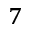Convert formula to latex. <formula><loc_0><loc_0><loc_500><loc_500>^ { 7 }</formula> 